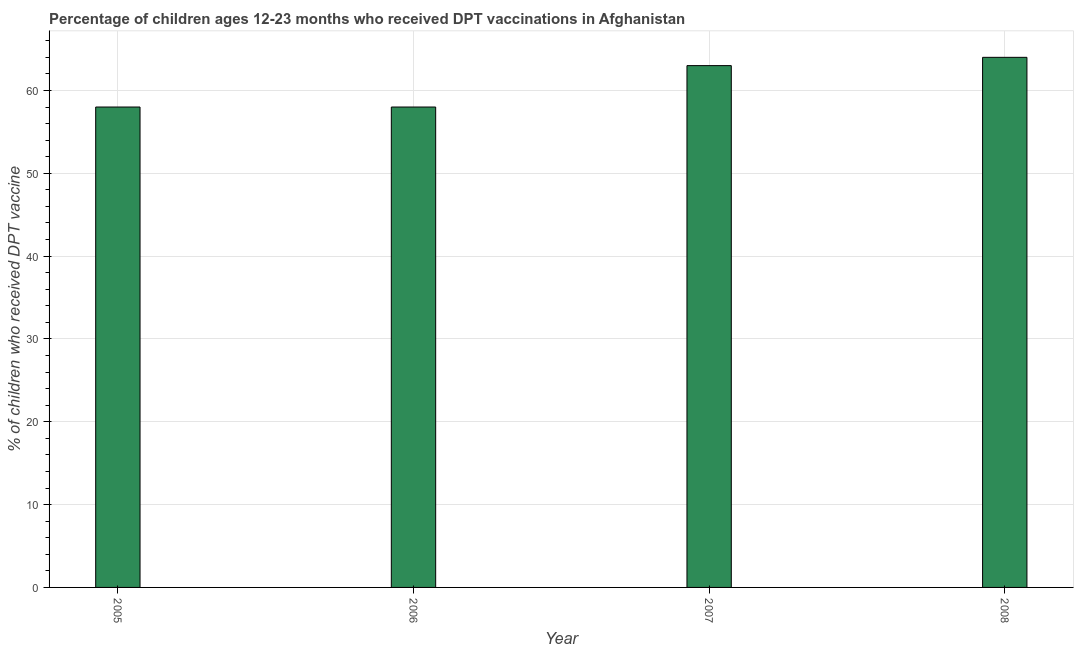What is the title of the graph?
Offer a terse response. Percentage of children ages 12-23 months who received DPT vaccinations in Afghanistan. What is the label or title of the Y-axis?
Offer a terse response. % of children who received DPT vaccine. What is the percentage of children who received dpt vaccine in 2005?
Provide a succinct answer. 58. Across all years, what is the maximum percentage of children who received dpt vaccine?
Provide a short and direct response. 64. Across all years, what is the minimum percentage of children who received dpt vaccine?
Your answer should be very brief. 58. In which year was the percentage of children who received dpt vaccine maximum?
Provide a short and direct response. 2008. In which year was the percentage of children who received dpt vaccine minimum?
Give a very brief answer. 2005. What is the sum of the percentage of children who received dpt vaccine?
Your answer should be very brief. 243. What is the median percentage of children who received dpt vaccine?
Give a very brief answer. 60.5. In how many years, is the percentage of children who received dpt vaccine greater than 52 %?
Ensure brevity in your answer.  4. What is the ratio of the percentage of children who received dpt vaccine in 2005 to that in 2007?
Your answer should be compact. 0.92. Is the difference between the percentage of children who received dpt vaccine in 2007 and 2008 greater than the difference between any two years?
Make the answer very short. No. In how many years, is the percentage of children who received dpt vaccine greater than the average percentage of children who received dpt vaccine taken over all years?
Ensure brevity in your answer.  2. How many bars are there?
Offer a very short reply. 4. Are the values on the major ticks of Y-axis written in scientific E-notation?
Give a very brief answer. No. What is the % of children who received DPT vaccine in 2008?
Ensure brevity in your answer.  64. What is the difference between the % of children who received DPT vaccine in 2005 and 2006?
Give a very brief answer. 0. What is the difference between the % of children who received DPT vaccine in 2005 and 2008?
Provide a succinct answer. -6. What is the difference between the % of children who received DPT vaccine in 2007 and 2008?
Ensure brevity in your answer.  -1. What is the ratio of the % of children who received DPT vaccine in 2005 to that in 2006?
Keep it short and to the point. 1. What is the ratio of the % of children who received DPT vaccine in 2005 to that in 2007?
Give a very brief answer. 0.92. What is the ratio of the % of children who received DPT vaccine in 2005 to that in 2008?
Your answer should be compact. 0.91. What is the ratio of the % of children who received DPT vaccine in 2006 to that in 2007?
Your answer should be compact. 0.92. What is the ratio of the % of children who received DPT vaccine in 2006 to that in 2008?
Provide a short and direct response. 0.91. What is the ratio of the % of children who received DPT vaccine in 2007 to that in 2008?
Give a very brief answer. 0.98. 